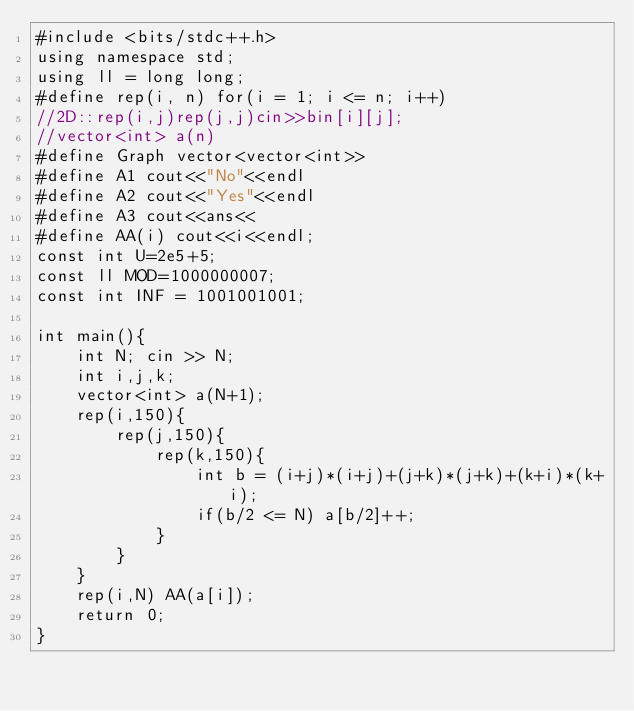Convert code to text. <code><loc_0><loc_0><loc_500><loc_500><_C++_>#include <bits/stdc++.h>
using namespace std;
using ll = long long;
#define rep(i, n) for(i = 1; i <= n; i++)
//2D::rep(i,j)rep(j,j)cin>>bin[i][j];
//vector<int> a(n)
#define Graph vector<vector<int>>
#define A1 cout<<"No"<<endl
#define A2 cout<<"Yes"<<endl
#define A3 cout<<ans<<
#define AA(i) cout<<i<<endl;
const int U=2e5+5;
const ll MOD=1000000007;
const int INF = 1001001001;

int main(){
    int N; cin >> N;
    int i,j,k;
    vector<int> a(N+1);
    rep(i,150){
        rep(j,150){
            rep(k,150){
                int b = (i+j)*(i+j)+(j+k)*(j+k)+(k+i)*(k+i);
                if(b/2 <= N) a[b/2]++;
            }
        }
    }
    rep(i,N) AA(a[i]);
    return 0;
}</code> 